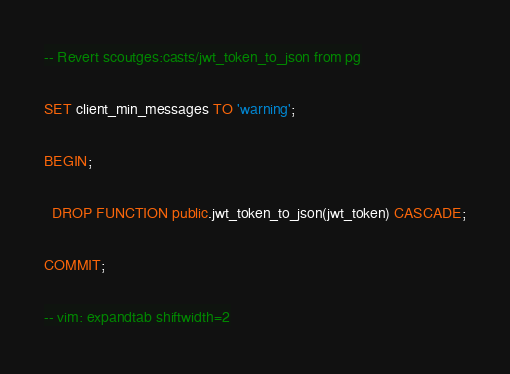<code> <loc_0><loc_0><loc_500><loc_500><_SQL_>-- Revert scoutges:casts/jwt_token_to_json from pg

SET client_min_messages TO 'warning';

BEGIN;

  DROP FUNCTION public.jwt_token_to_json(jwt_token) CASCADE;

COMMIT;

-- vim: expandtab shiftwidth=2
</code> 